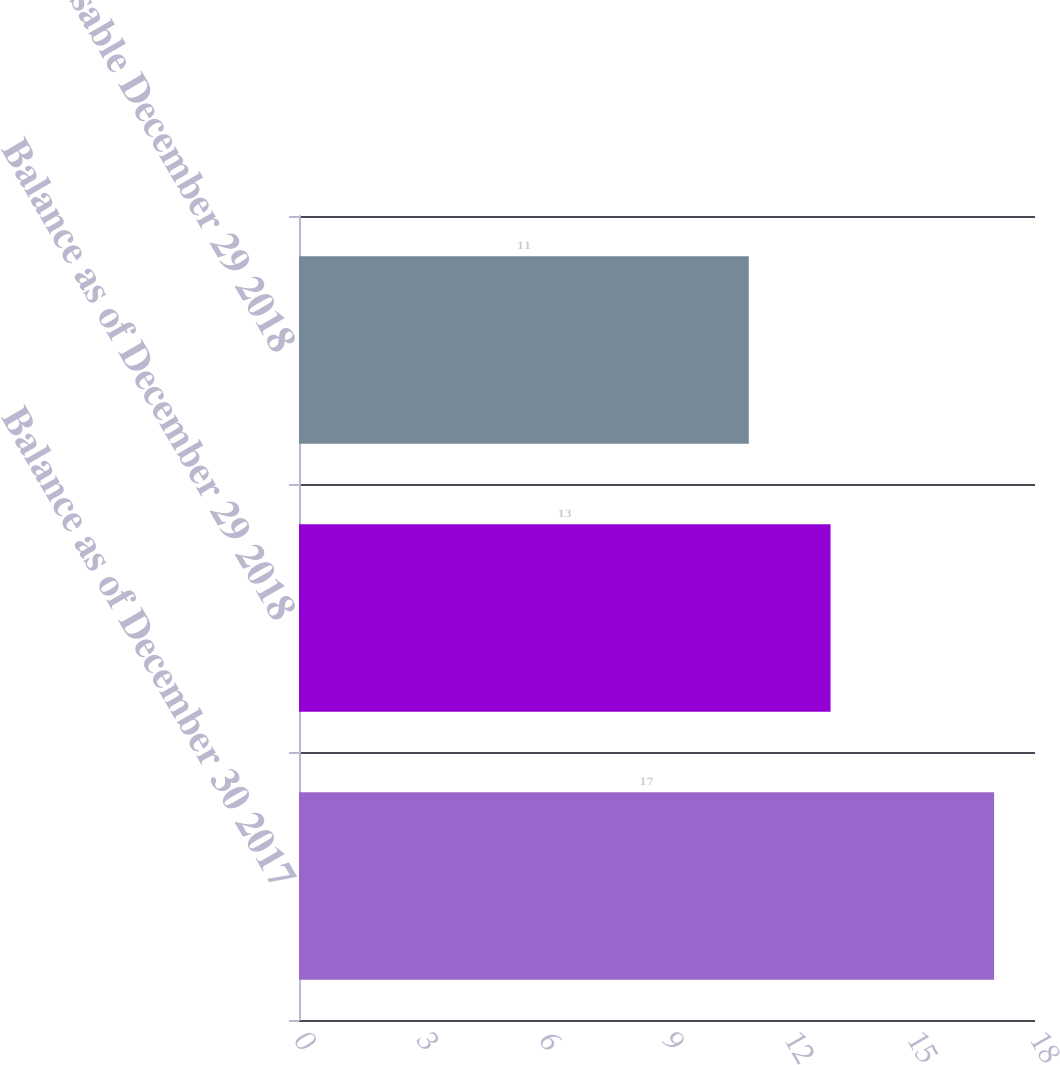Convert chart to OTSL. <chart><loc_0><loc_0><loc_500><loc_500><bar_chart><fcel>Balance as of December 30 2017<fcel>Balance as of December 29 2018<fcel>Exercisable December 29 2018<nl><fcel>17<fcel>13<fcel>11<nl></chart> 